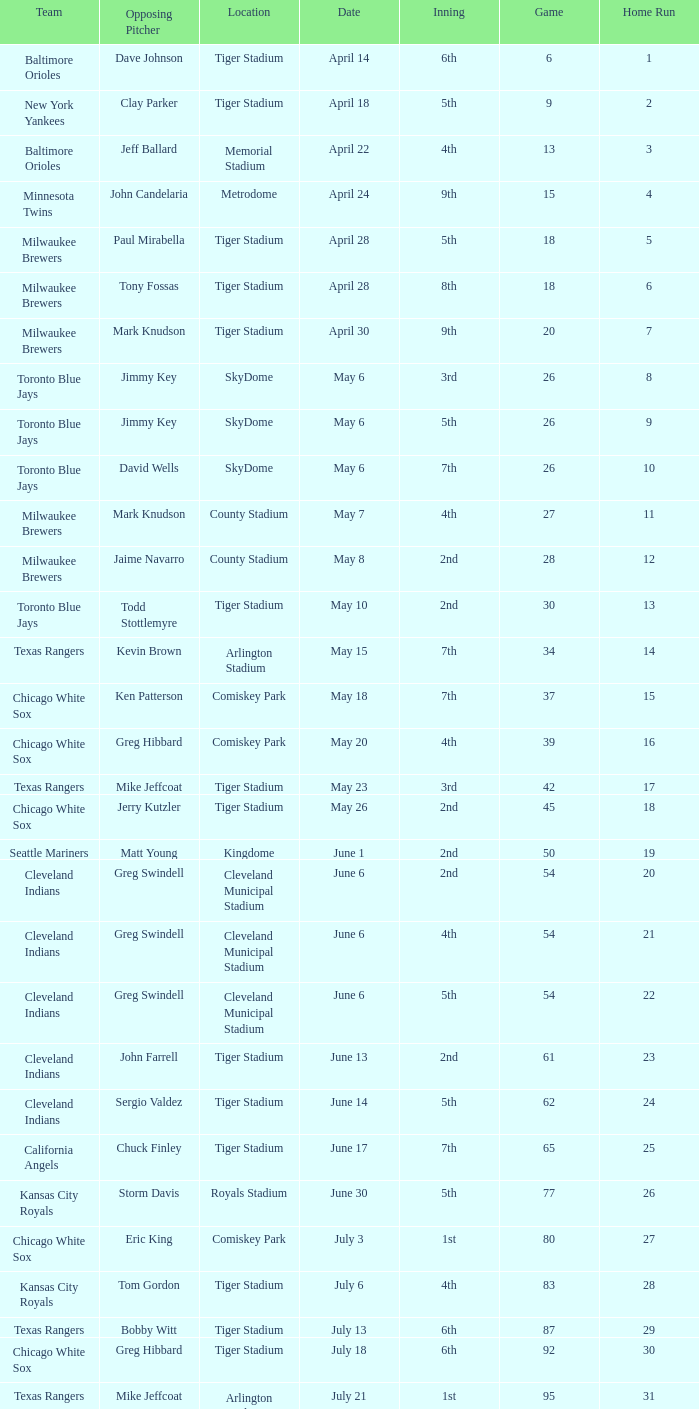When Efrain Valdez was pitching, what was the highest home run? 39.0. Parse the table in full. {'header': ['Team', 'Opposing Pitcher', 'Location', 'Date', 'Inning', 'Game', 'Home Run'], 'rows': [['Baltimore Orioles', 'Dave Johnson', 'Tiger Stadium', 'April 14', '6th', '6', '1'], ['New York Yankees', 'Clay Parker', 'Tiger Stadium', 'April 18', '5th', '9', '2'], ['Baltimore Orioles', 'Jeff Ballard', 'Memorial Stadium', 'April 22', '4th', '13', '3'], ['Minnesota Twins', 'John Candelaria', 'Metrodome', 'April 24', '9th', '15', '4'], ['Milwaukee Brewers', 'Paul Mirabella', 'Tiger Stadium', 'April 28', '5th', '18', '5'], ['Milwaukee Brewers', 'Tony Fossas', 'Tiger Stadium', 'April 28', '8th', '18', '6'], ['Milwaukee Brewers', 'Mark Knudson', 'Tiger Stadium', 'April 30', '9th', '20', '7'], ['Toronto Blue Jays', 'Jimmy Key', 'SkyDome', 'May 6', '3rd', '26', '8'], ['Toronto Blue Jays', 'Jimmy Key', 'SkyDome', 'May 6', '5th', '26', '9'], ['Toronto Blue Jays', 'David Wells', 'SkyDome', 'May 6', '7th', '26', '10'], ['Milwaukee Brewers', 'Mark Knudson', 'County Stadium', 'May 7', '4th', '27', '11'], ['Milwaukee Brewers', 'Jaime Navarro', 'County Stadium', 'May 8', '2nd', '28', '12'], ['Toronto Blue Jays', 'Todd Stottlemyre', 'Tiger Stadium', 'May 10', '2nd', '30', '13'], ['Texas Rangers', 'Kevin Brown', 'Arlington Stadium', 'May 15', '7th', '34', '14'], ['Chicago White Sox', 'Ken Patterson', 'Comiskey Park', 'May 18', '7th', '37', '15'], ['Chicago White Sox', 'Greg Hibbard', 'Comiskey Park', 'May 20', '4th', '39', '16'], ['Texas Rangers', 'Mike Jeffcoat', 'Tiger Stadium', 'May 23', '3rd', '42', '17'], ['Chicago White Sox', 'Jerry Kutzler', 'Tiger Stadium', 'May 26', '2nd', '45', '18'], ['Seattle Mariners', 'Matt Young', 'Kingdome', 'June 1', '2nd', '50', '19'], ['Cleveland Indians', 'Greg Swindell', 'Cleveland Municipal Stadium', 'June 6', '2nd', '54', '20'], ['Cleveland Indians', 'Greg Swindell', 'Cleveland Municipal Stadium', 'June 6', '4th', '54', '21'], ['Cleveland Indians', 'Greg Swindell', 'Cleveland Municipal Stadium', 'June 6', '5th', '54', '22'], ['Cleveland Indians', 'John Farrell', 'Tiger Stadium', 'June 13', '2nd', '61', '23'], ['Cleveland Indians', 'Sergio Valdez', 'Tiger Stadium', 'June 14', '5th', '62', '24'], ['California Angels', 'Chuck Finley', 'Tiger Stadium', 'June 17', '7th', '65', '25'], ['Kansas City Royals', 'Storm Davis', 'Royals Stadium', 'June 30', '5th', '77', '26'], ['Chicago White Sox', 'Eric King', 'Comiskey Park', 'July 3', '1st', '80', '27'], ['Kansas City Royals', 'Tom Gordon', 'Tiger Stadium', 'July 6', '4th', '83', '28'], ['Texas Rangers', 'Bobby Witt', 'Tiger Stadium', 'July 13', '6th', '87', '29'], ['Chicago White Sox', 'Greg Hibbard', 'Tiger Stadium', 'July 18', '6th', '92', '30'], ['Texas Rangers', 'Mike Jeffcoat', 'Arlington Stadium', 'July 21', '1st', '95', '31'], ['Baltimore Orioles', 'John Mitchell', 'Tiger Stadium', 'July 24', '3rd', '98', '32'], ['New York Yankees', 'Dave LaPoint', 'Yankee Stadium', 'July 30', '4th', '104', '33'], ['Boston Red Sox', 'Greg Harris', 'Fenway Park', 'August 3', '2nd', '108', '34'], ['Toronto Blue Jays', 'Jimmy Key', 'Skydome', 'August 7', '9th', '111', '35'], ['Cleveland Indians', 'Jeff Shaw', 'Cleveland Stadium', 'August 13', '1st', '117', '36'], ['Milwaukee Brewers', 'Ron Robinson', 'Tiger Stadium', 'August 16', '3rd', '120', '37'], ['Cleveland Indians', 'Tom Candiotti', 'Tiger Stadium', 'August 17', '6th', '121', '38'], ['Cleveland Indians', 'Efrain Valdez', 'Tiger Stadium', 'August 18', '3rd', '122', '39'], ['Oakland Athletics', 'Dave Stewart', 'Tiger Stadium', 'August 25', '1st', '127', '40'], ['Oakland Athletics', 'Dave Stewart', 'Tiger Stadium', 'August 25', '4th', '127', '41'], ['Seattle Mariners', 'Matt Young', 'Kingdome', 'August 29', '8th', '130', '42'], ['Toronto Blue Jays', 'Jimmy Key', 'Tiger Stadium', 'September 3', '6th', '135', '43'], ['Toronto Blue Jays', 'David Wells', 'Tiger Stadium', 'September 5', '6th', '137', '44'], ['Milwaukee Brewers', 'Ted Higuera', 'County Stadium', 'September 7', '6th', '139', '45'], ['New York Yankees', 'Mike Witt', 'Tiger Stadium', 'September 13', '9th', '145', '46'], ['New York Yankees', 'Mark Leiter', 'Tiger Stadium', 'September 16', '5th', '148', '47'], ['Oakland Athletics', 'Mike Moore', 'Oakland Coliseum', 'September 23', '2nd', '153', '48'], ['Boston Red Sox', 'Dennis Lamp', 'Tiger Stadium', 'September 27', '8th', '156', '49'], ['New York Yankees', 'Steve Adkins', 'Yankee Stadium', 'October 3', '4th', '162', '50'], ['New York Yankees', 'Alan Mills', 'Yankee Stadium', 'October 3', '8th', '162', '51']]} 